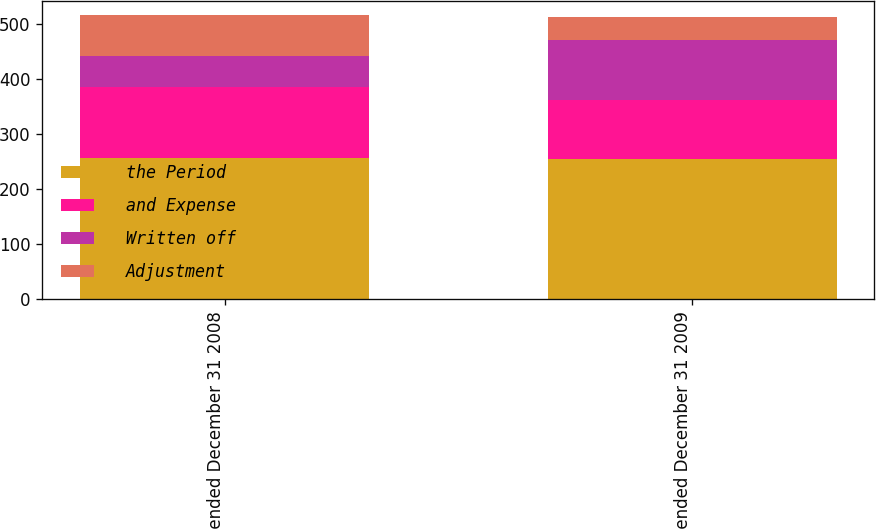Convert chart to OTSL. <chart><loc_0><loc_0><loc_500><loc_500><stacked_bar_chart><ecel><fcel>Year ended December 31 2008<fcel>Year ended December 31 2009<nl><fcel>the Period<fcel>257<fcel>255<nl><fcel>and Expense<fcel>128<fcel>106<nl><fcel>Written off<fcel>56<fcel>109<nl><fcel>Adjustment<fcel>74<fcel>41<nl></chart> 